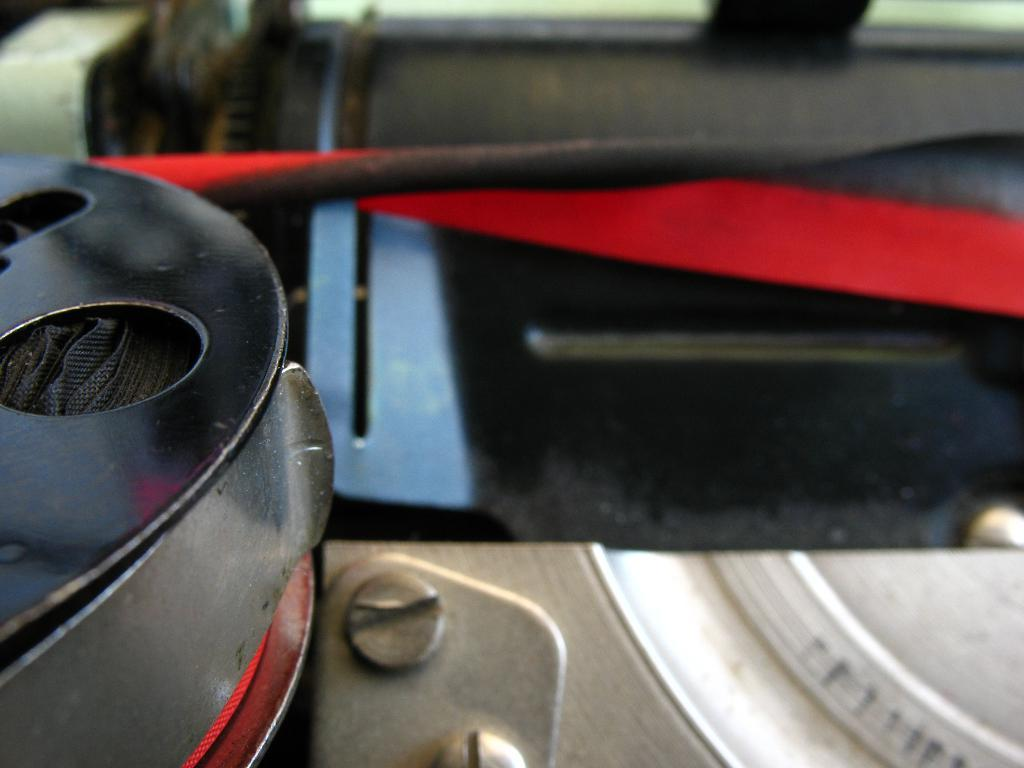What colors can be seen in the objects present in the image? The objects in the image are blue, black, red, grey, and white. Can you describe the variety of colors in the image? The image features a mix of blue, black, red, grey, and white objects. What is the opinion of the tramp about the objects in the image? There is no tramp present in the image, so it is not possible to determine their opinion about the objects. Are there any balloons in the image? There is no mention of balloons in the provided facts, so it cannot be determined if they are present in the image. 